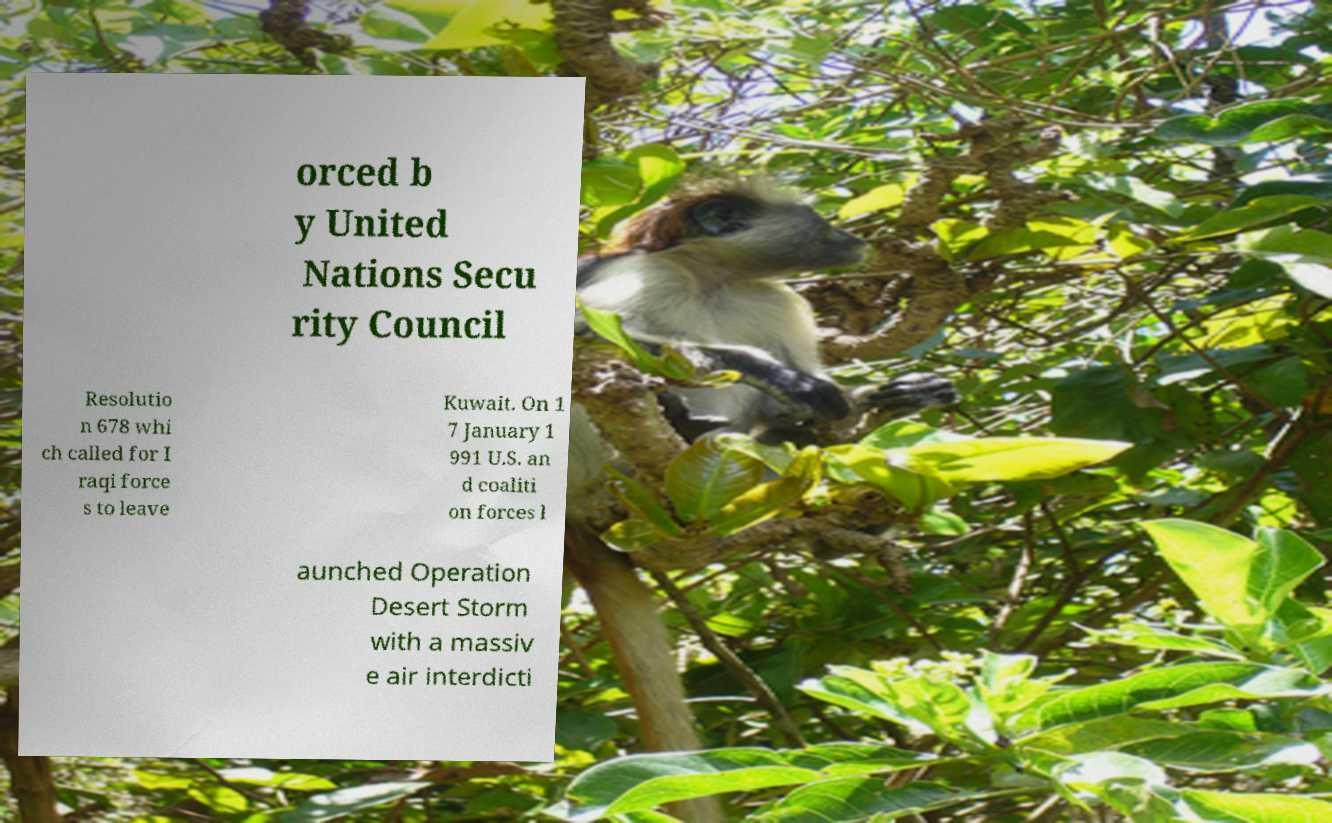I need the written content from this picture converted into text. Can you do that? orced b y United Nations Secu rity Council Resolutio n 678 whi ch called for I raqi force s to leave Kuwait. On 1 7 January 1 991 U.S. an d coaliti on forces l aunched Operation Desert Storm with a massiv e air interdicti 